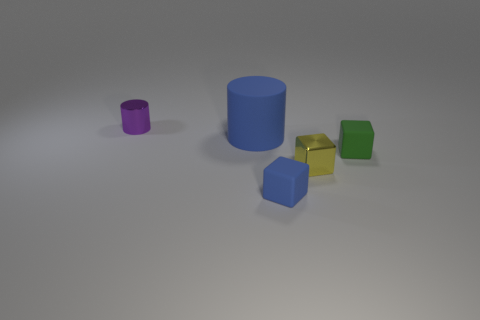Are there any other things that have the same size as the blue cylinder?
Your answer should be very brief. No. What number of rubber things have the same size as the metallic cylinder?
Your answer should be very brief. 2. How many objects are matte cylinders or things that are to the left of the blue cylinder?
Offer a very short reply. 2. What is the shape of the large matte object?
Keep it short and to the point. Cylinder. Is the color of the metal cube the same as the big matte cylinder?
Your answer should be very brief. No. There is a cylinder that is the same size as the yellow shiny block; what color is it?
Make the answer very short. Purple. What number of red objects are either big objects or small matte objects?
Your response must be concise. 0. Is the number of metallic cubes greater than the number of brown shiny blocks?
Ensure brevity in your answer.  Yes. There is a cylinder that is in front of the purple shiny cylinder; is it the same size as the rubber thing in front of the tiny green object?
Provide a succinct answer. No. There is a metal cube in front of the blue cylinder that is behind the matte object to the right of the blue cube; what is its color?
Make the answer very short. Yellow. 